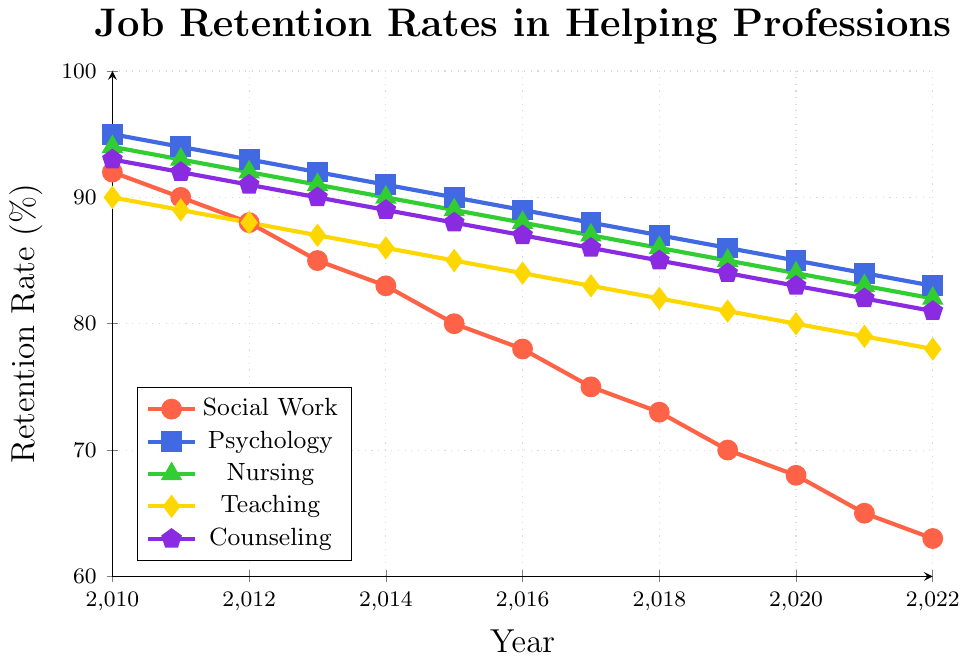What profession had the highest job retention rate in 2010? Look at the beginning of the lines in the figure and compare the heights. The highest point in 2010 is the blue line representing Psychology.
Answer: Psychology How much did the retention rate for Social Work decrease from 2010 to 2022? Subtract the retention rate of Social Work in 2022 from that in 2010: 92 (2010) - 63 (2022) = 29.
Answer: 29 Which profession consistently had the second highest retention rate from 2010 to 2022? By comparing the heights of the lines over all years, Nursing consistently had the second highest retention rate after Psychology.
Answer: Nursing Between which consecutive years did Social Work experience the largest drop in retention rates? Calculate the year-on-year decrease for each pair of consecutive years for Social Work and identify the largest: from 2010 to 2011 (92 - 90 = 2), 2011 to 2012 (90 - 88 = 2), ..., 2021 to 2022 (65 - 63 = 2). The largest drop was 3% that occurred from 2013 to 2014 (85 - 83) and from 2016 to 2017 (78 - 75).
Answer: 2013 to 2014, 2016 to 2017 Which profession showed the most stable retention rate trend from 2010 to 2022? Identify the profession with the most gradual and consistent slope. Psychology appears to have the most stable trend with a steady decline.
Answer: Psychology What is the overall trend observed in job retention rates across all helping professions from 2010 to 2022? All the lines representing the job retention rates are declining over the years.
Answer: Decline In which year did Teaching have the same job retention rate as Social Work? Compare the values for all years and find that in the year 2018 both were at 73%.
Answer: 2018 What is the average job retention rate for Counseling over the period 2010 to 2022? Sum the retention rates for Counseling across all years and divide by the number of years: (93+92+91+90+89+88+87+86+85+84+83+82+81)/13 = 87.
Answer: 87 